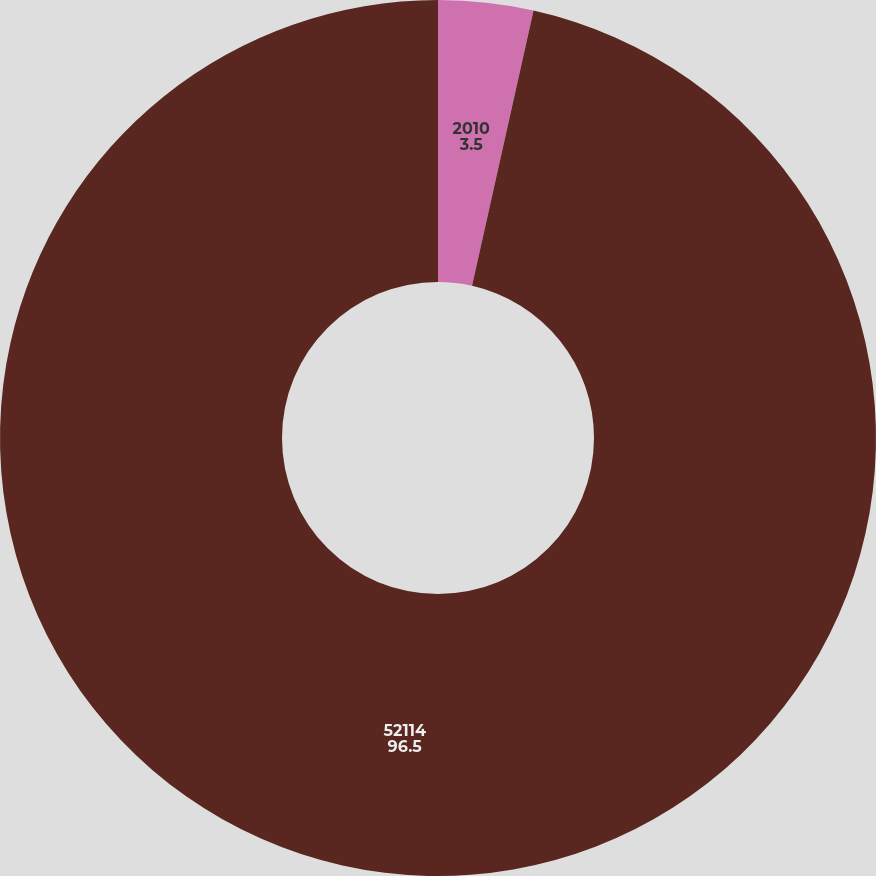Convert chart. <chart><loc_0><loc_0><loc_500><loc_500><pie_chart><fcel>2010<fcel>52114<nl><fcel>3.5%<fcel>96.5%<nl></chart> 